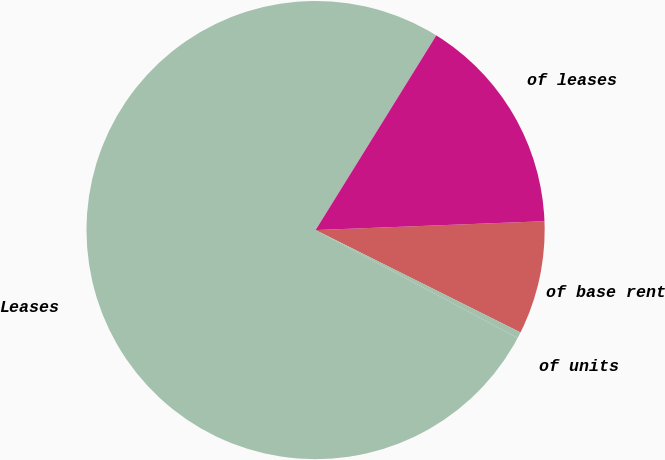<chart> <loc_0><loc_0><loc_500><loc_500><pie_chart><fcel>of base rent<fcel>of units<fcel>Leases<fcel>of leases<nl><fcel>7.99%<fcel>0.43%<fcel>76.03%<fcel>15.55%<nl></chart> 